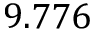Convert formula to latex. <formula><loc_0><loc_0><loc_500><loc_500>9 . 7 7 6</formula> 